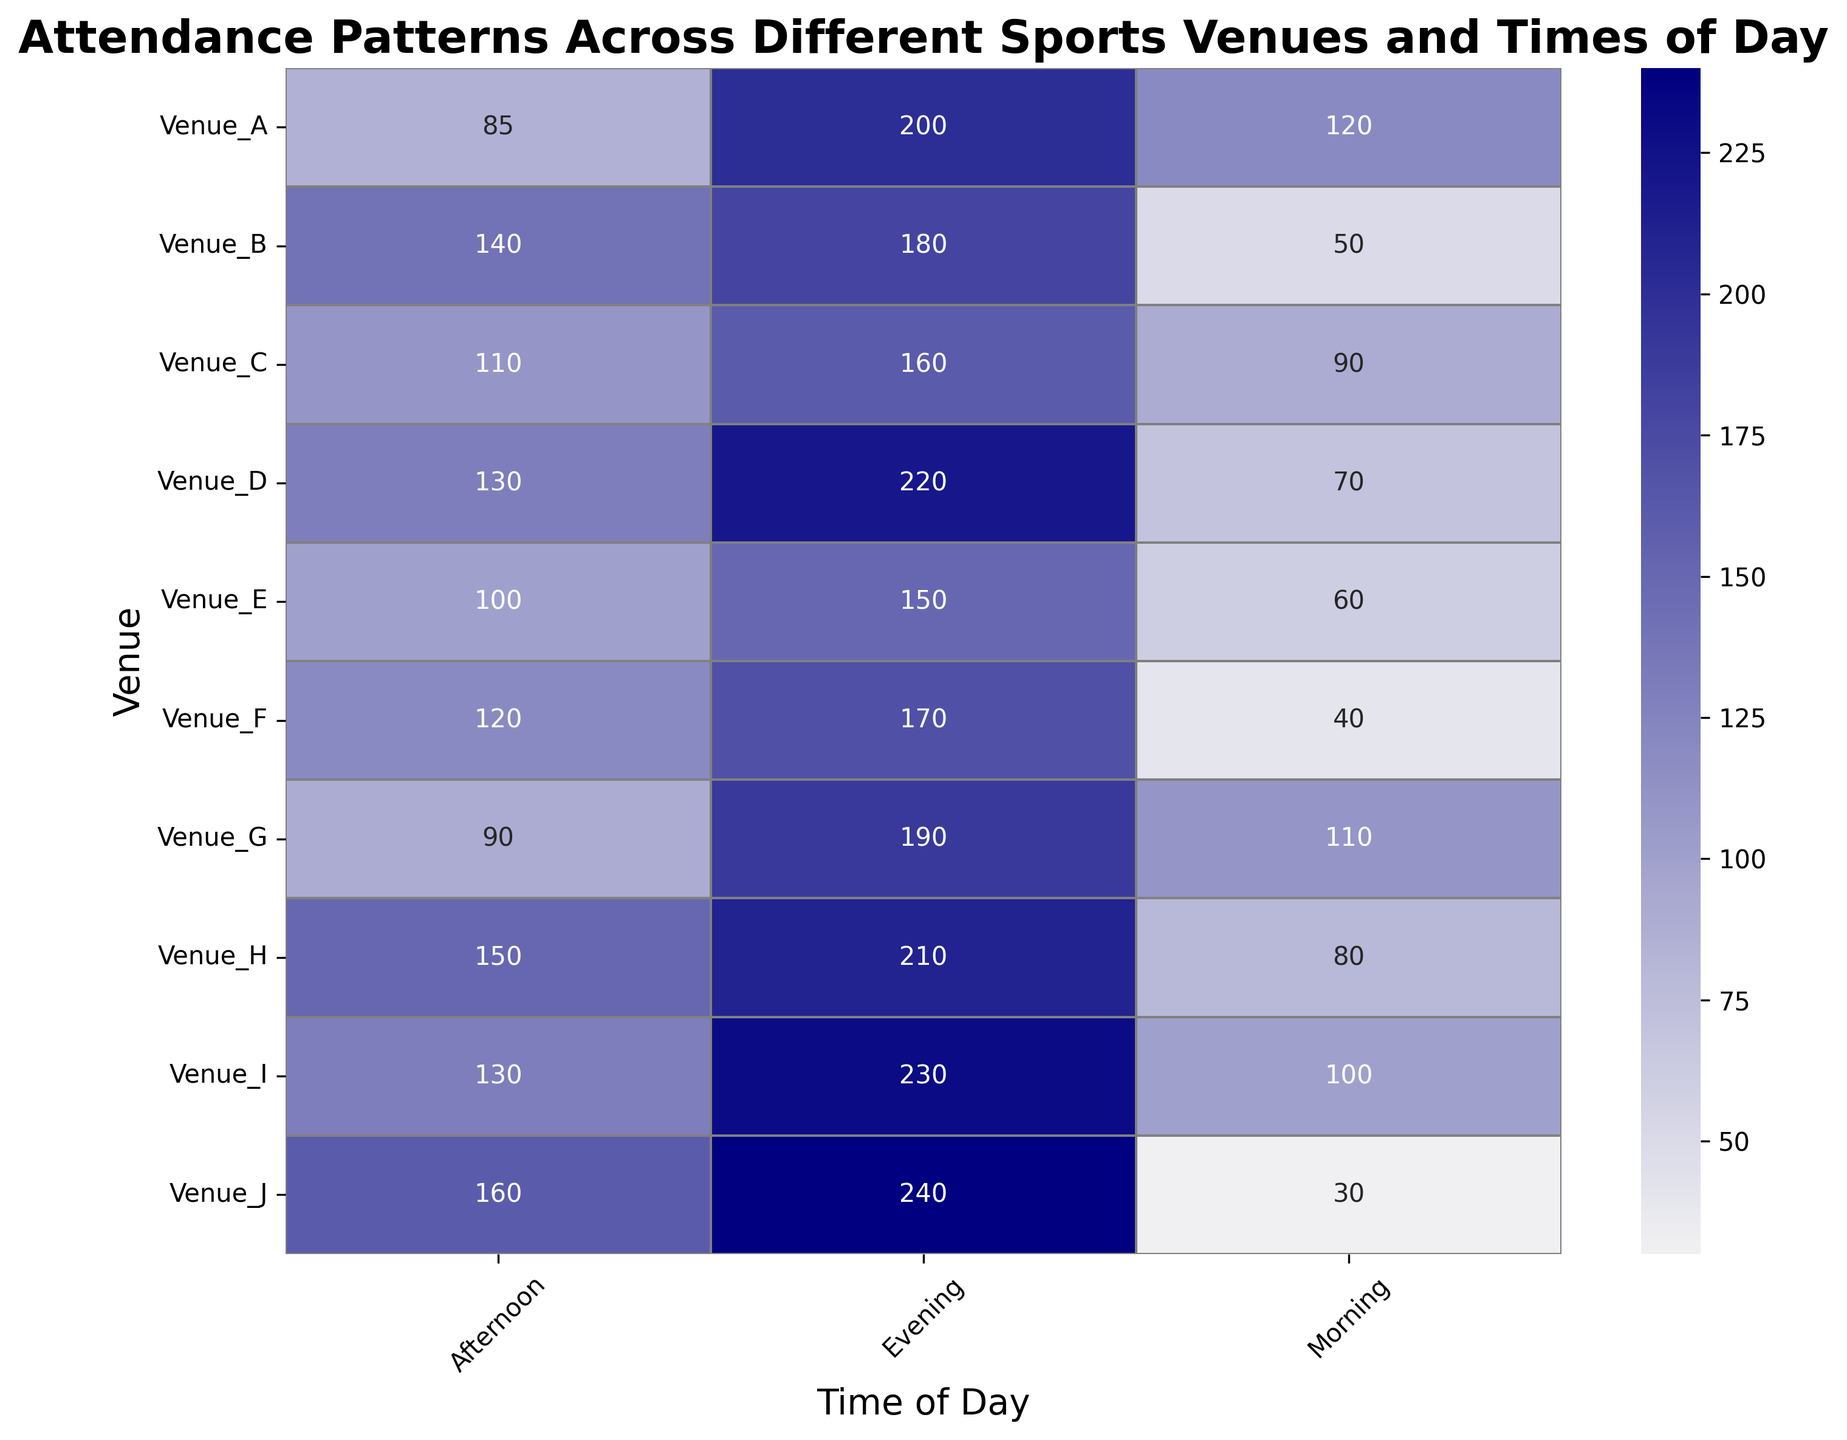What time of day generally has the highest attendance for most venues? The heatmap shows higher attendance numbers using darker shades. By scanning across the "Evening" column, you can observe that most venues have the darkest shades in the evening, indicating the highest attendance compared to morning and afternoon.
Answer: Evening Which venue has the highest attendance in the morning? By looking at the "Morning" row on the heatmap, Venue_A shows the darkest color among all morning values. The annotated value also confirms this with 120 attendees.
Answer: Venue_A How does the attendance at Venue_J in the afternoon compare to attendance at Venue_C in the evening? By comparing the heatmap values for Venue_J (160 attendees in the afternoon) and Venue_C (160 attendees in the evening), both are the same.
Answer: Equal What is the average attendance across all venues during the afternoon? Sum all afternoon attendance values and then divide by the number of venues: (85 + 140 + 110 + 130 + 100 + 120 + 90 + 150 + 130 + 160) = 1215, and (1215 / 10) = 121.5
Answer: 121.5 Which venue has the largest variation in attendance across different times of the day? Determine the difference between max and min attendance for each venue: Venue_A (200-85=115), Venue_B (180-50=130), Venue_C (160-90=70), Venue_D (220-70=150), Venue_E (150-60=90), Venue_F (170-40=130), Venue_G (190-90=100), Venue_H (210-80=130), Venue_I (230-100=130), Venue_J (240-30=210). Venue_J has the largest variation with a 210 attendee difference.
Answer: Venue_J For venues B and C, when do they experience their peak attendance and how much is it? For Venue_B, the peak attendance is in the evening with 180 attendees. For Venue_C, the peak attendance is also in the evening with 160 attendees.
Answer: Evening, 180 (Venue_B); Evening, 160 (Venue_C) What is the total attendance for Venue_H across all times of the day? Sum the attendance for Venue_H: (80 + 150 + 210) = 440
Answer: 440 Which venue has the lowest attendance during the morning, and what is the attendance value? By scanning the "Morning" column in the heatmap, Venue_J shows the lightest shade, indicating the lowest attendance with a value of 30 attendees.
Answer: Venue_J, 30 Is attendance in the afternoon generally greater than in the morning across all venues? Compare each venue's morning and afternoon attendance: 
Venue_A: 85 > 120 (False)
Venue_B: 140 > 50 (True)
Venue_C: 110 > 90 (True)
Venue_D: 130 > 70 (True)
Venue_E: 100 > 60 (True)
Venue_F: 120 > 40 (True)
Venue_G: 90 > 110 (False)
Venue_H: 150 > 80 (True)
Venue_I: 130 > 100 (True)
Venue_J: 160 > 30 (True)
Since only 2 out of 10 venues show higher attendance in the morning than the afternoon, the general pattern is that afternoon attendance is greater.
Answer: Yes 